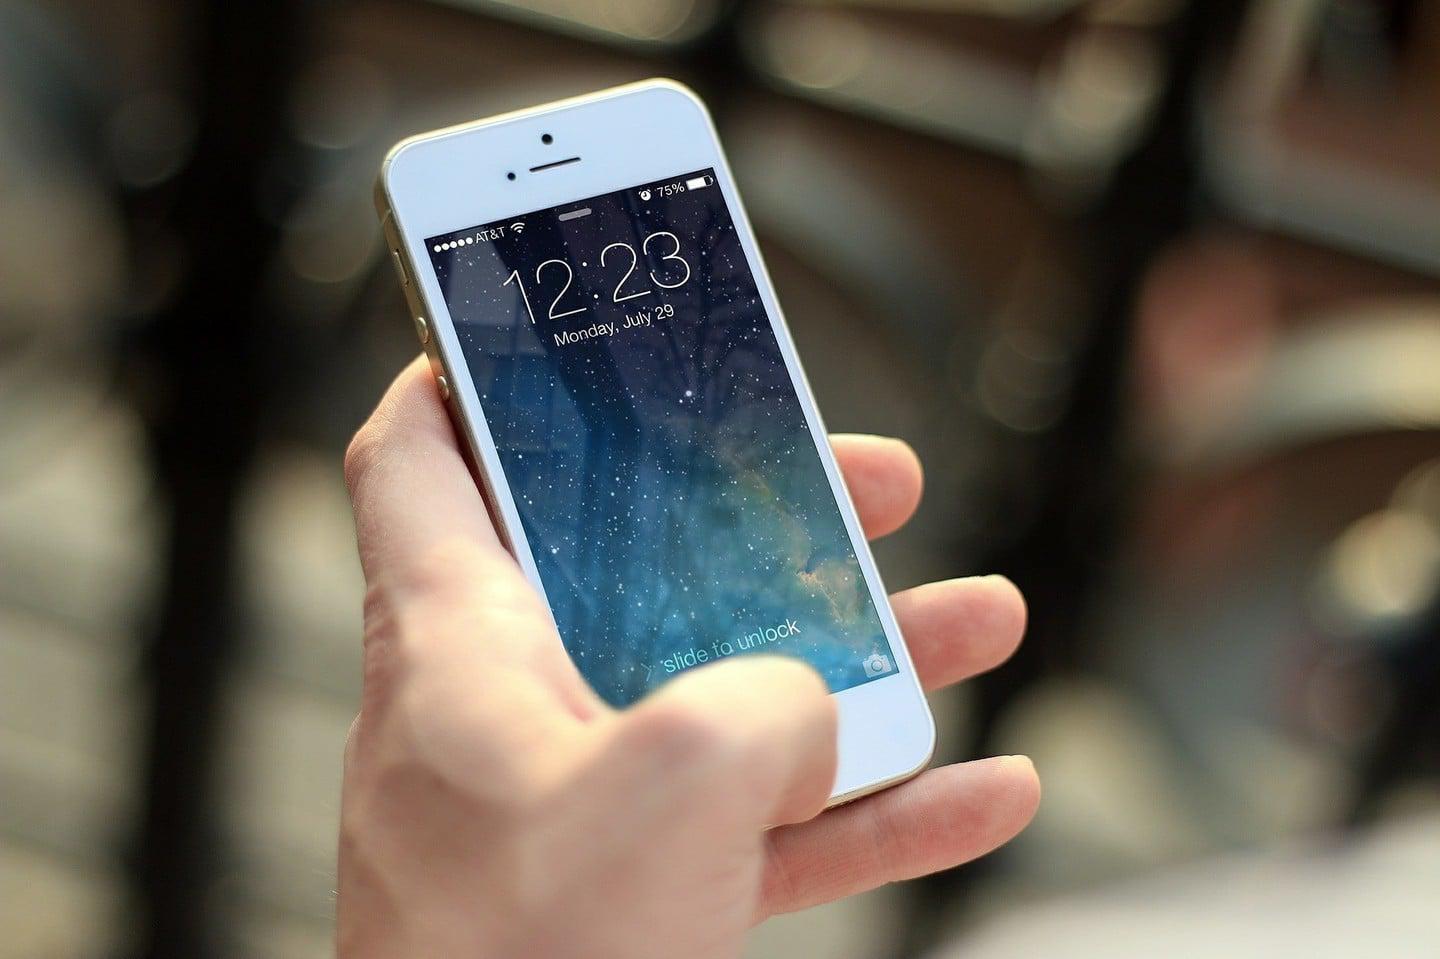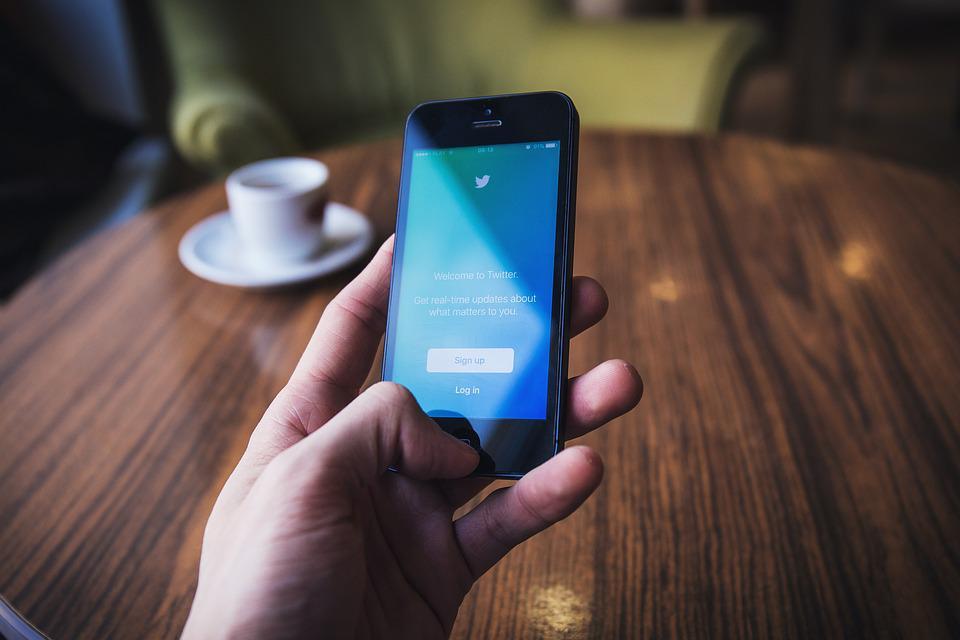The first image is the image on the left, the second image is the image on the right. Analyze the images presented: Is the assertion "The right image contains a human hand holding a smart phone." valid? Answer yes or no. Yes. The first image is the image on the left, the second image is the image on the right. For the images shown, is this caption "There are exactly two phones in total." true? Answer yes or no. Yes. 